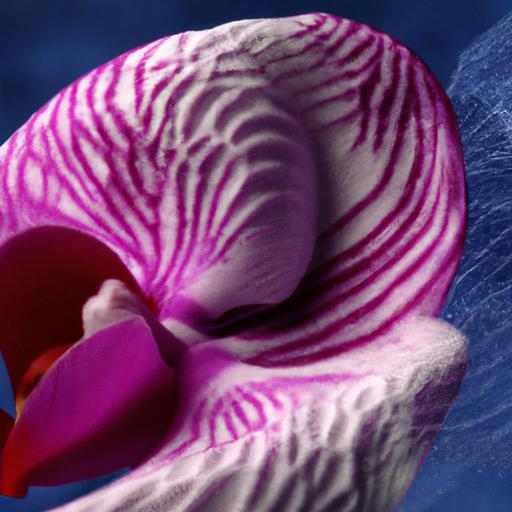What does the color pattern of the petals suggest about the flower's habitat? The vibrant and distinct color pattern of the orchid's petals suggests it is adapted to attract pollinators, such as bees and butterflies. This unique adaptation is common among orchids that thrive in diverse and competitive ecosystems, where attracting the right pollinator is crucial for their reproduction. 